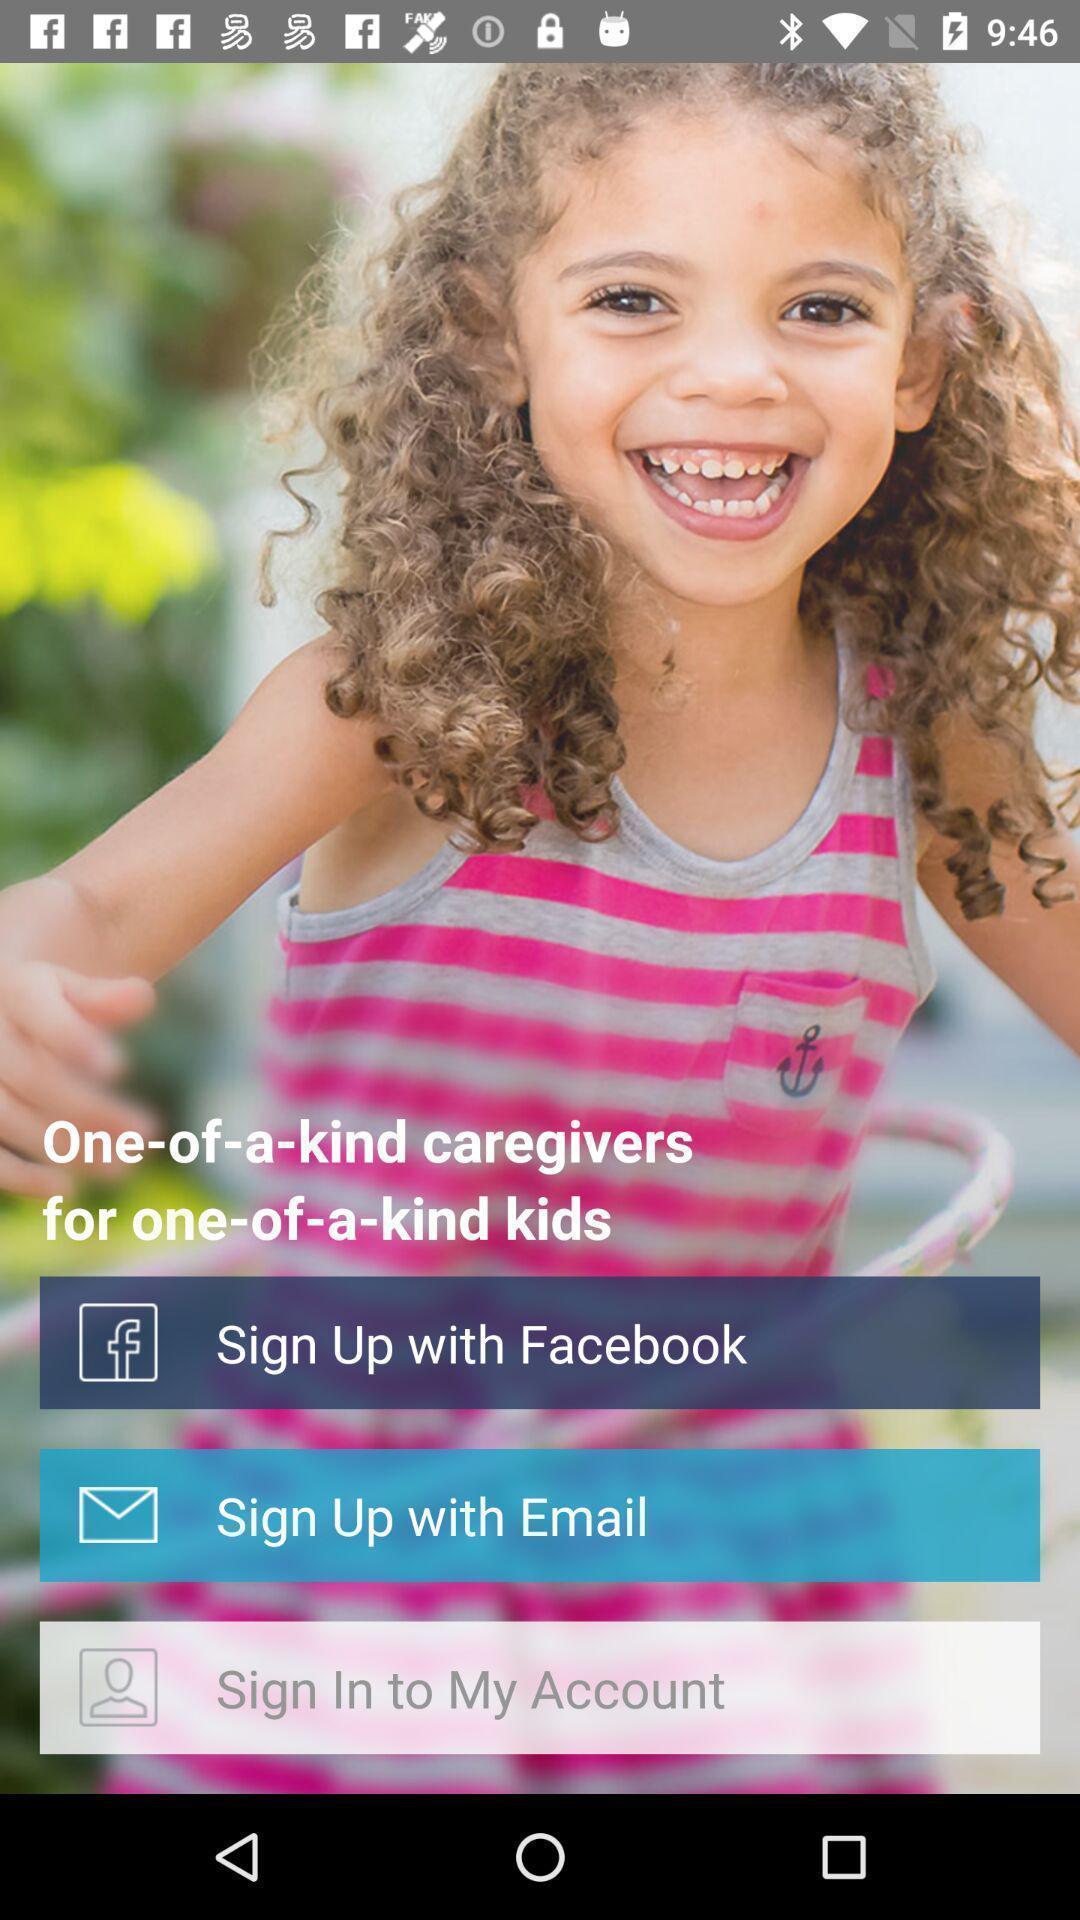Give me a narrative description of this picture. Sign up/ sign in page through social application. 